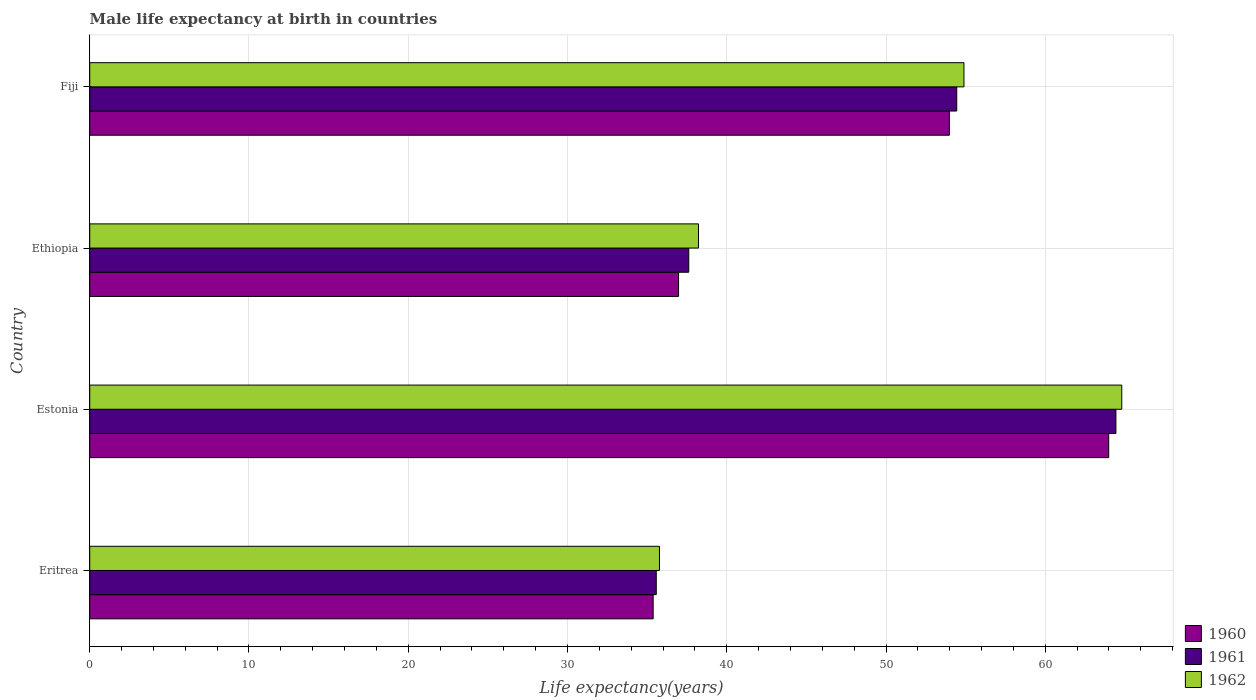How many groups of bars are there?
Ensure brevity in your answer.  4. What is the label of the 2nd group of bars from the top?
Provide a short and direct response. Ethiopia. In how many cases, is the number of bars for a given country not equal to the number of legend labels?
Your response must be concise. 0. What is the male life expectancy at birth in 1961 in Eritrea?
Provide a short and direct response. 35.57. Across all countries, what is the maximum male life expectancy at birth in 1962?
Provide a succinct answer. 64.8. Across all countries, what is the minimum male life expectancy at birth in 1962?
Provide a short and direct response. 35.77. In which country was the male life expectancy at birth in 1962 maximum?
Give a very brief answer. Estonia. In which country was the male life expectancy at birth in 1962 minimum?
Your answer should be compact. Eritrea. What is the total male life expectancy at birth in 1962 in the graph?
Your answer should be compact. 193.7. What is the difference between the male life expectancy at birth in 1960 in Estonia and that in Fiji?
Your answer should be compact. 10.01. What is the difference between the male life expectancy at birth in 1962 in Eritrea and the male life expectancy at birth in 1961 in Ethiopia?
Provide a succinct answer. -1.84. What is the average male life expectancy at birth in 1960 per country?
Offer a terse response. 47.58. What is the difference between the male life expectancy at birth in 1962 and male life expectancy at birth in 1960 in Estonia?
Make the answer very short. 0.82. What is the ratio of the male life expectancy at birth in 1960 in Estonia to that in Fiji?
Provide a short and direct response. 1.19. Is the male life expectancy at birth in 1962 in Eritrea less than that in Ethiopia?
Provide a succinct answer. Yes. What is the difference between the highest and the second highest male life expectancy at birth in 1962?
Provide a succinct answer. 9.91. What is the difference between the highest and the lowest male life expectancy at birth in 1962?
Offer a terse response. 29.03. In how many countries, is the male life expectancy at birth in 1962 greater than the average male life expectancy at birth in 1962 taken over all countries?
Provide a succinct answer. 2. What does the 1st bar from the top in Estonia represents?
Offer a terse response. 1962. Is it the case that in every country, the sum of the male life expectancy at birth in 1961 and male life expectancy at birth in 1962 is greater than the male life expectancy at birth in 1960?
Offer a terse response. Yes. How many bars are there?
Provide a succinct answer. 12. Are all the bars in the graph horizontal?
Give a very brief answer. Yes. Does the graph contain grids?
Ensure brevity in your answer.  Yes. Where does the legend appear in the graph?
Make the answer very short. Bottom right. What is the title of the graph?
Give a very brief answer. Male life expectancy at birth in countries. What is the label or title of the X-axis?
Your response must be concise. Life expectancy(years). What is the Life expectancy(years) in 1960 in Eritrea?
Provide a short and direct response. 35.38. What is the Life expectancy(years) in 1961 in Eritrea?
Provide a succinct answer. 35.57. What is the Life expectancy(years) of 1962 in Eritrea?
Your answer should be compact. 35.77. What is the Life expectancy(years) in 1960 in Estonia?
Offer a very short reply. 63.98. What is the Life expectancy(years) in 1961 in Estonia?
Offer a very short reply. 64.44. What is the Life expectancy(years) in 1962 in Estonia?
Keep it short and to the point. 64.8. What is the Life expectancy(years) in 1960 in Ethiopia?
Your answer should be very brief. 36.97. What is the Life expectancy(years) in 1961 in Ethiopia?
Your response must be concise. 37.62. What is the Life expectancy(years) in 1962 in Ethiopia?
Give a very brief answer. 38.23. What is the Life expectancy(years) in 1960 in Fiji?
Give a very brief answer. 53.98. What is the Life expectancy(years) of 1961 in Fiji?
Your answer should be compact. 54.44. What is the Life expectancy(years) of 1962 in Fiji?
Offer a terse response. 54.9. Across all countries, what is the maximum Life expectancy(years) of 1960?
Your response must be concise. 63.98. Across all countries, what is the maximum Life expectancy(years) of 1961?
Provide a short and direct response. 64.44. Across all countries, what is the maximum Life expectancy(years) of 1962?
Keep it short and to the point. 64.8. Across all countries, what is the minimum Life expectancy(years) in 1960?
Provide a succinct answer. 35.38. Across all countries, what is the minimum Life expectancy(years) in 1961?
Provide a short and direct response. 35.57. Across all countries, what is the minimum Life expectancy(years) of 1962?
Your response must be concise. 35.77. What is the total Life expectancy(years) of 1960 in the graph?
Offer a very short reply. 190.32. What is the total Life expectancy(years) of 1961 in the graph?
Ensure brevity in your answer.  192.07. What is the total Life expectancy(years) of 1962 in the graph?
Offer a very short reply. 193.7. What is the difference between the Life expectancy(years) of 1960 in Eritrea and that in Estonia?
Provide a succinct answer. -28.61. What is the difference between the Life expectancy(years) in 1961 in Eritrea and that in Estonia?
Your response must be concise. -28.86. What is the difference between the Life expectancy(years) in 1962 in Eritrea and that in Estonia?
Provide a short and direct response. -29.03. What is the difference between the Life expectancy(years) of 1960 in Eritrea and that in Ethiopia?
Provide a succinct answer. -1.59. What is the difference between the Life expectancy(years) of 1961 in Eritrea and that in Ethiopia?
Provide a short and direct response. -2.04. What is the difference between the Life expectancy(years) in 1962 in Eritrea and that in Ethiopia?
Provide a succinct answer. -2.45. What is the difference between the Life expectancy(years) of 1960 in Eritrea and that in Fiji?
Give a very brief answer. -18.6. What is the difference between the Life expectancy(years) of 1961 in Eritrea and that in Fiji?
Provide a succinct answer. -18.87. What is the difference between the Life expectancy(years) in 1962 in Eritrea and that in Fiji?
Offer a terse response. -19.12. What is the difference between the Life expectancy(years) in 1960 in Estonia and that in Ethiopia?
Provide a succinct answer. 27.01. What is the difference between the Life expectancy(years) of 1961 in Estonia and that in Ethiopia?
Offer a very short reply. 26.82. What is the difference between the Life expectancy(years) in 1962 in Estonia and that in Ethiopia?
Offer a very short reply. 26.58. What is the difference between the Life expectancy(years) in 1960 in Estonia and that in Fiji?
Keep it short and to the point. 10.01. What is the difference between the Life expectancy(years) of 1961 in Estonia and that in Fiji?
Offer a terse response. 9.99. What is the difference between the Life expectancy(years) in 1962 in Estonia and that in Fiji?
Keep it short and to the point. 9.91. What is the difference between the Life expectancy(years) of 1960 in Ethiopia and that in Fiji?
Your answer should be compact. -17. What is the difference between the Life expectancy(years) of 1961 in Ethiopia and that in Fiji?
Ensure brevity in your answer.  -16.83. What is the difference between the Life expectancy(years) of 1962 in Ethiopia and that in Fiji?
Provide a short and direct response. -16.67. What is the difference between the Life expectancy(years) in 1960 in Eritrea and the Life expectancy(years) in 1961 in Estonia?
Keep it short and to the point. -29.06. What is the difference between the Life expectancy(years) in 1960 in Eritrea and the Life expectancy(years) in 1962 in Estonia?
Your response must be concise. -29.43. What is the difference between the Life expectancy(years) in 1961 in Eritrea and the Life expectancy(years) in 1962 in Estonia?
Offer a terse response. -29.23. What is the difference between the Life expectancy(years) in 1960 in Eritrea and the Life expectancy(years) in 1961 in Ethiopia?
Your answer should be compact. -2.24. What is the difference between the Life expectancy(years) of 1960 in Eritrea and the Life expectancy(years) of 1962 in Ethiopia?
Offer a terse response. -2.85. What is the difference between the Life expectancy(years) in 1961 in Eritrea and the Life expectancy(years) in 1962 in Ethiopia?
Provide a succinct answer. -2.65. What is the difference between the Life expectancy(years) of 1960 in Eritrea and the Life expectancy(years) of 1961 in Fiji?
Your answer should be very brief. -19.06. What is the difference between the Life expectancy(years) in 1960 in Eritrea and the Life expectancy(years) in 1962 in Fiji?
Provide a short and direct response. -19.52. What is the difference between the Life expectancy(years) of 1961 in Eritrea and the Life expectancy(years) of 1962 in Fiji?
Provide a short and direct response. -19.32. What is the difference between the Life expectancy(years) of 1960 in Estonia and the Life expectancy(years) of 1961 in Ethiopia?
Your answer should be compact. 26.37. What is the difference between the Life expectancy(years) of 1960 in Estonia and the Life expectancy(years) of 1962 in Ethiopia?
Give a very brief answer. 25.76. What is the difference between the Life expectancy(years) in 1961 in Estonia and the Life expectancy(years) in 1962 in Ethiopia?
Your answer should be very brief. 26.21. What is the difference between the Life expectancy(years) in 1960 in Estonia and the Life expectancy(years) in 1961 in Fiji?
Give a very brief answer. 9.54. What is the difference between the Life expectancy(years) in 1960 in Estonia and the Life expectancy(years) in 1962 in Fiji?
Give a very brief answer. 9.09. What is the difference between the Life expectancy(years) of 1961 in Estonia and the Life expectancy(years) of 1962 in Fiji?
Ensure brevity in your answer.  9.54. What is the difference between the Life expectancy(years) in 1960 in Ethiopia and the Life expectancy(years) in 1961 in Fiji?
Your answer should be compact. -17.47. What is the difference between the Life expectancy(years) of 1960 in Ethiopia and the Life expectancy(years) of 1962 in Fiji?
Provide a short and direct response. -17.92. What is the difference between the Life expectancy(years) of 1961 in Ethiopia and the Life expectancy(years) of 1962 in Fiji?
Your response must be concise. -17.28. What is the average Life expectancy(years) in 1960 per country?
Your answer should be compact. 47.58. What is the average Life expectancy(years) in 1961 per country?
Your answer should be very brief. 48.02. What is the average Life expectancy(years) of 1962 per country?
Provide a succinct answer. 48.42. What is the difference between the Life expectancy(years) in 1960 and Life expectancy(years) in 1961 in Eritrea?
Provide a short and direct response. -0.2. What is the difference between the Life expectancy(years) in 1960 and Life expectancy(years) in 1962 in Eritrea?
Your answer should be very brief. -0.4. What is the difference between the Life expectancy(years) of 1961 and Life expectancy(years) of 1962 in Eritrea?
Your answer should be compact. -0.2. What is the difference between the Life expectancy(years) in 1960 and Life expectancy(years) in 1961 in Estonia?
Provide a succinct answer. -0.45. What is the difference between the Life expectancy(years) of 1960 and Life expectancy(years) of 1962 in Estonia?
Keep it short and to the point. -0.82. What is the difference between the Life expectancy(years) in 1961 and Life expectancy(years) in 1962 in Estonia?
Provide a short and direct response. -0.37. What is the difference between the Life expectancy(years) in 1960 and Life expectancy(years) in 1961 in Ethiopia?
Ensure brevity in your answer.  -0.64. What is the difference between the Life expectancy(years) of 1960 and Life expectancy(years) of 1962 in Ethiopia?
Make the answer very short. -1.25. What is the difference between the Life expectancy(years) in 1961 and Life expectancy(years) in 1962 in Ethiopia?
Your response must be concise. -0.61. What is the difference between the Life expectancy(years) in 1960 and Life expectancy(years) in 1961 in Fiji?
Offer a terse response. -0.46. What is the difference between the Life expectancy(years) in 1960 and Life expectancy(years) in 1962 in Fiji?
Your answer should be compact. -0.92. What is the difference between the Life expectancy(years) of 1961 and Life expectancy(years) of 1962 in Fiji?
Provide a succinct answer. -0.45. What is the ratio of the Life expectancy(years) in 1960 in Eritrea to that in Estonia?
Make the answer very short. 0.55. What is the ratio of the Life expectancy(years) in 1961 in Eritrea to that in Estonia?
Your answer should be compact. 0.55. What is the ratio of the Life expectancy(years) in 1962 in Eritrea to that in Estonia?
Give a very brief answer. 0.55. What is the ratio of the Life expectancy(years) in 1960 in Eritrea to that in Ethiopia?
Offer a very short reply. 0.96. What is the ratio of the Life expectancy(years) of 1961 in Eritrea to that in Ethiopia?
Provide a succinct answer. 0.95. What is the ratio of the Life expectancy(years) in 1962 in Eritrea to that in Ethiopia?
Provide a succinct answer. 0.94. What is the ratio of the Life expectancy(years) in 1960 in Eritrea to that in Fiji?
Make the answer very short. 0.66. What is the ratio of the Life expectancy(years) in 1961 in Eritrea to that in Fiji?
Give a very brief answer. 0.65. What is the ratio of the Life expectancy(years) in 1962 in Eritrea to that in Fiji?
Provide a succinct answer. 0.65. What is the ratio of the Life expectancy(years) in 1960 in Estonia to that in Ethiopia?
Your answer should be compact. 1.73. What is the ratio of the Life expectancy(years) in 1961 in Estonia to that in Ethiopia?
Ensure brevity in your answer.  1.71. What is the ratio of the Life expectancy(years) of 1962 in Estonia to that in Ethiopia?
Your response must be concise. 1.7. What is the ratio of the Life expectancy(years) of 1960 in Estonia to that in Fiji?
Your answer should be compact. 1.19. What is the ratio of the Life expectancy(years) in 1961 in Estonia to that in Fiji?
Give a very brief answer. 1.18. What is the ratio of the Life expectancy(years) of 1962 in Estonia to that in Fiji?
Keep it short and to the point. 1.18. What is the ratio of the Life expectancy(years) in 1960 in Ethiopia to that in Fiji?
Ensure brevity in your answer.  0.69. What is the ratio of the Life expectancy(years) in 1961 in Ethiopia to that in Fiji?
Your answer should be compact. 0.69. What is the ratio of the Life expectancy(years) of 1962 in Ethiopia to that in Fiji?
Your answer should be compact. 0.7. What is the difference between the highest and the second highest Life expectancy(years) of 1960?
Your response must be concise. 10.01. What is the difference between the highest and the second highest Life expectancy(years) of 1961?
Your response must be concise. 9.99. What is the difference between the highest and the second highest Life expectancy(years) of 1962?
Keep it short and to the point. 9.91. What is the difference between the highest and the lowest Life expectancy(years) of 1960?
Offer a very short reply. 28.61. What is the difference between the highest and the lowest Life expectancy(years) in 1961?
Offer a terse response. 28.86. What is the difference between the highest and the lowest Life expectancy(years) in 1962?
Your response must be concise. 29.03. 